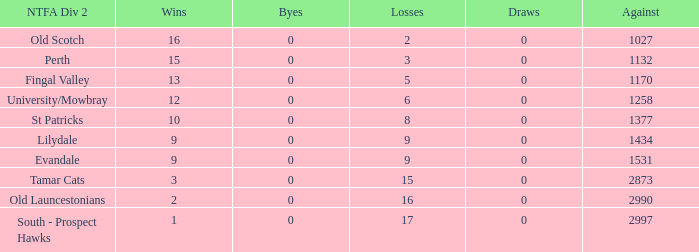What is the lowest number of draws of the NTFA Div 2 Lilydale? 0.0. 